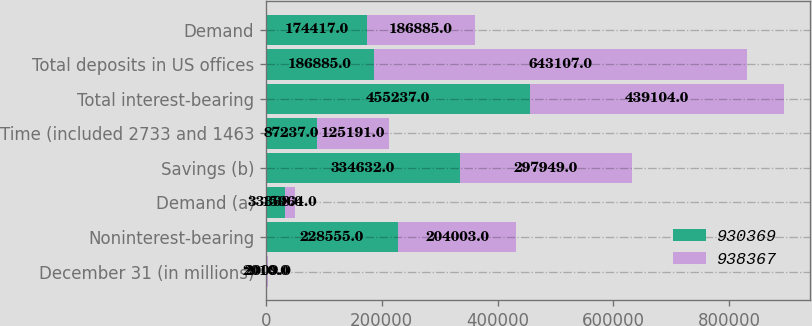<chart> <loc_0><loc_0><loc_500><loc_500><stacked_bar_chart><ecel><fcel>December 31 (in millions)<fcel>Noninterest-bearing<fcel>Demand (a)<fcel>Savings (b)<fcel>Time (included 2733 and 1463<fcel>Total interest-bearing<fcel>Total deposits in US offices<fcel>Demand<nl><fcel>930369<fcel>2010<fcel>228555<fcel>33368<fcel>334632<fcel>87237<fcel>455237<fcel>186885<fcel>174417<nl><fcel>938367<fcel>2009<fcel>204003<fcel>15964<fcel>297949<fcel>125191<fcel>439104<fcel>643107<fcel>186885<nl></chart> 